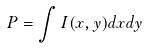Convert formula to latex. <formula><loc_0><loc_0><loc_500><loc_500>P = \int I ( x , y ) d x d y</formula> 